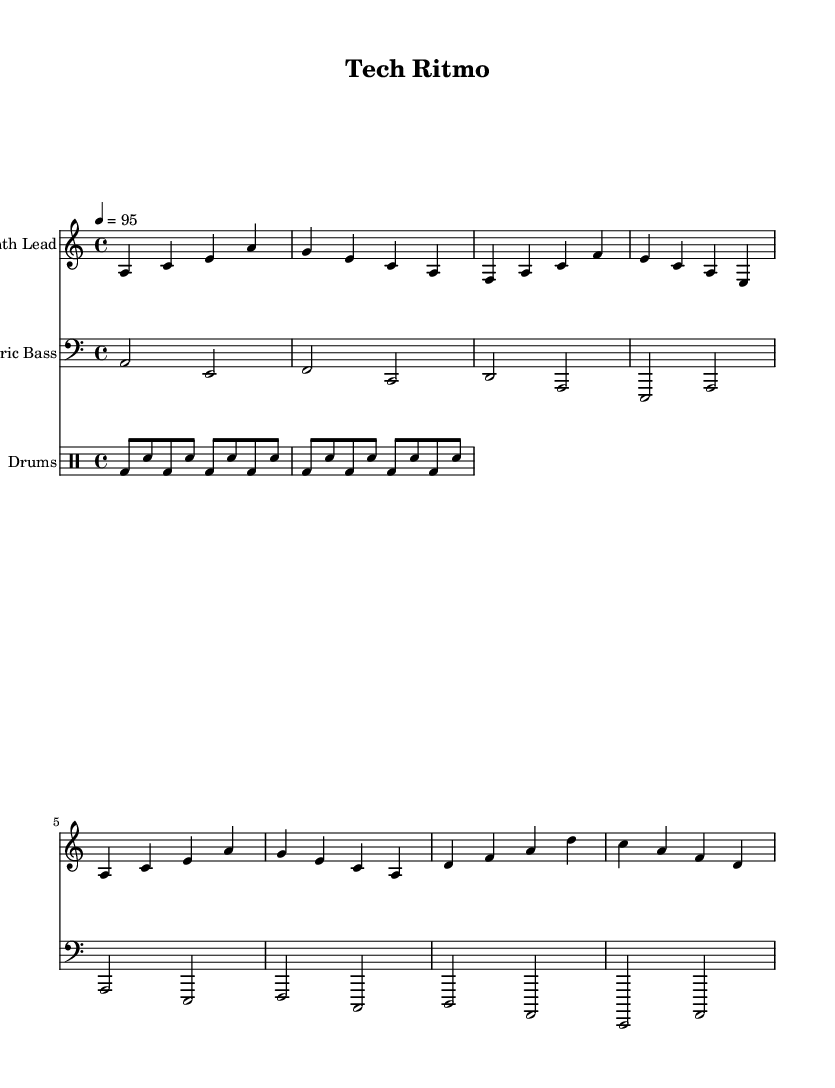What is the key signature of this music? The key signature indicates the pitches that are sharp or flat. Here, the key is A minor, which has no sharps or flats.
Answer: A minor What is the time signature of the piece? The time signature is found at the beginning of the music. In this case, it is 4/4, which means there are four beats in each measure and a quarter note gets one beat.
Answer: 4/4 What is the tempo marking? The tempo marking indicates how fast the music should be played. Here, it is marked as 4 = 95, meaning there should be 95 beats per minute.
Answer: 95 How many measures are in the synth lead section? To find the number of measures, we count the individual groups of notes separated by vertical lines. There are 8 measures in the synth lead part.
Answer: 8 What instruments are used in this arrangement? The instruments can be identified from the staff titles; there are three parts labeled as Synth Lead, Electric Bass, and Drums.
Answer: Synth Lead, Electric Bass, Drums What is the main theme of the lyrics? The lyrics reflect a celebration of technological innovation, as it discusses topics like technology, revolution, and the future in the context of music.
Answer: Technological innovation 